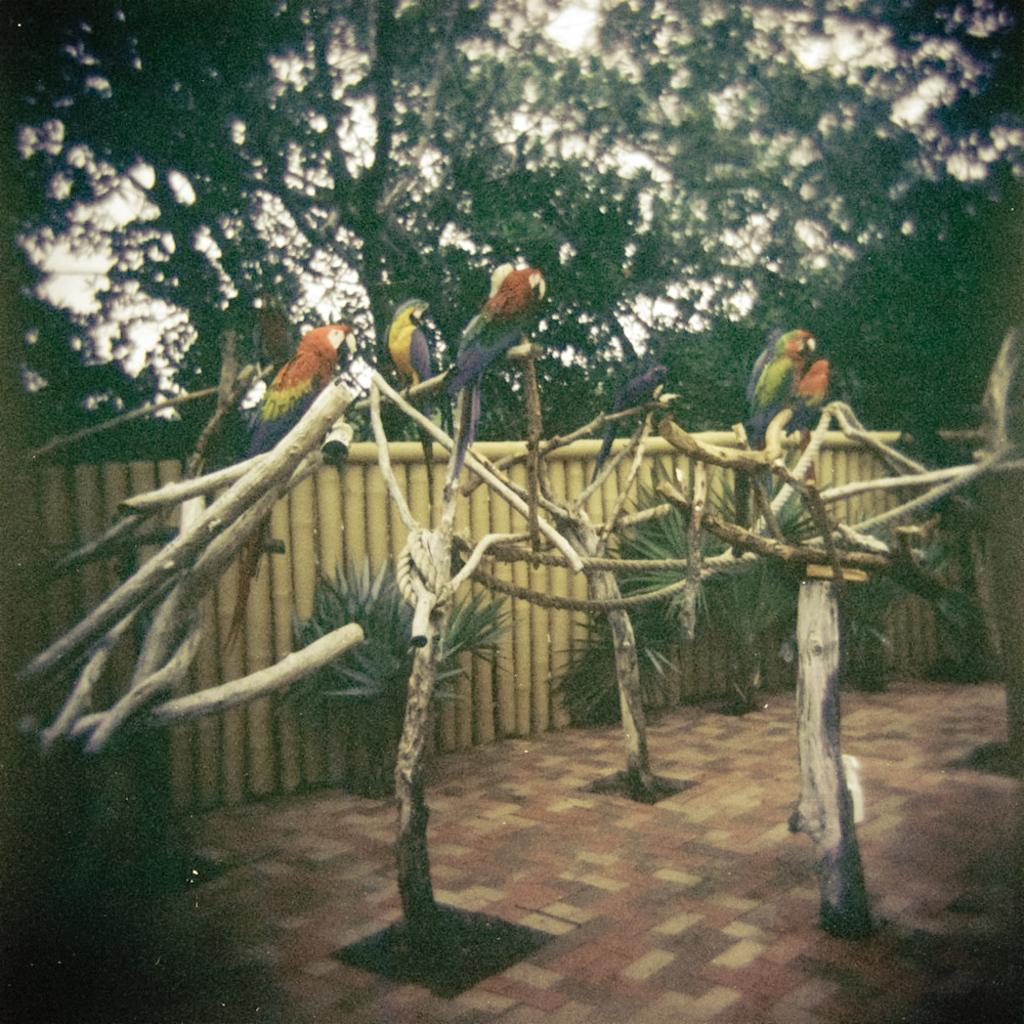What type of animals can be seen on the tree trunks in the image? There are birds on the tree trunks in the image. What is attached to the tree trunks? There is a rope attached to the tree trunks. What type of vegetation is present in the image? There are plants in the image. What type of barrier can be seen in the image? There is a wooden fence in the image. What can be seen in the background of the image? There is a tree in the background of the image. What type of collar is the bird wearing in the image? There are no collars visible on the birds in the image. Can you see the sea in the background of the image? The image does not show a sea or any body of water in the background; it features a tree. 